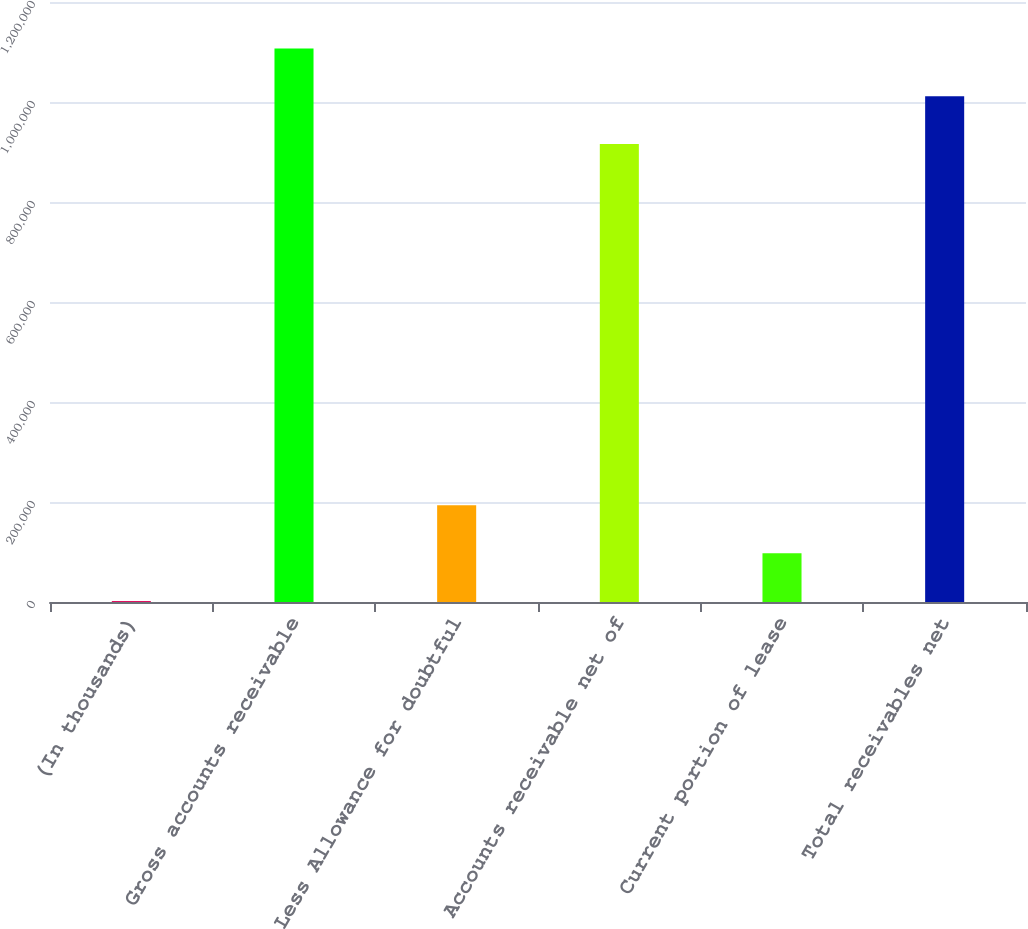<chart> <loc_0><loc_0><loc_500><loc_500><bar_chart><fcel>(In thousands)<fcel>Gross accounts receivable<fcel>Less Allowance for doubtful<fcel>Accounts receivable net of<fcel>Current portion of lease<fcel>Total receivables net<nl><fcel>2016<fcel>1.10718e+06<fcel>193381<fcel>915815<fcel>97698.7<fcel>1.0115e+06<nl></chart> 